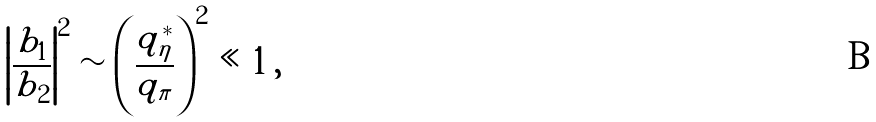Convert formula to latex. <formula><loc_0><loc_0><loc_500><loc_500>\left | \frac { b _ { 1 } } { b _ { \, 2 } } \right | ^ { 2 } \sim \left ( \frac { q _ { \eta } ^ { * } } { q _ { \pi } } \right ) ^ { 2 } \ll 1 \, ,</formula> 